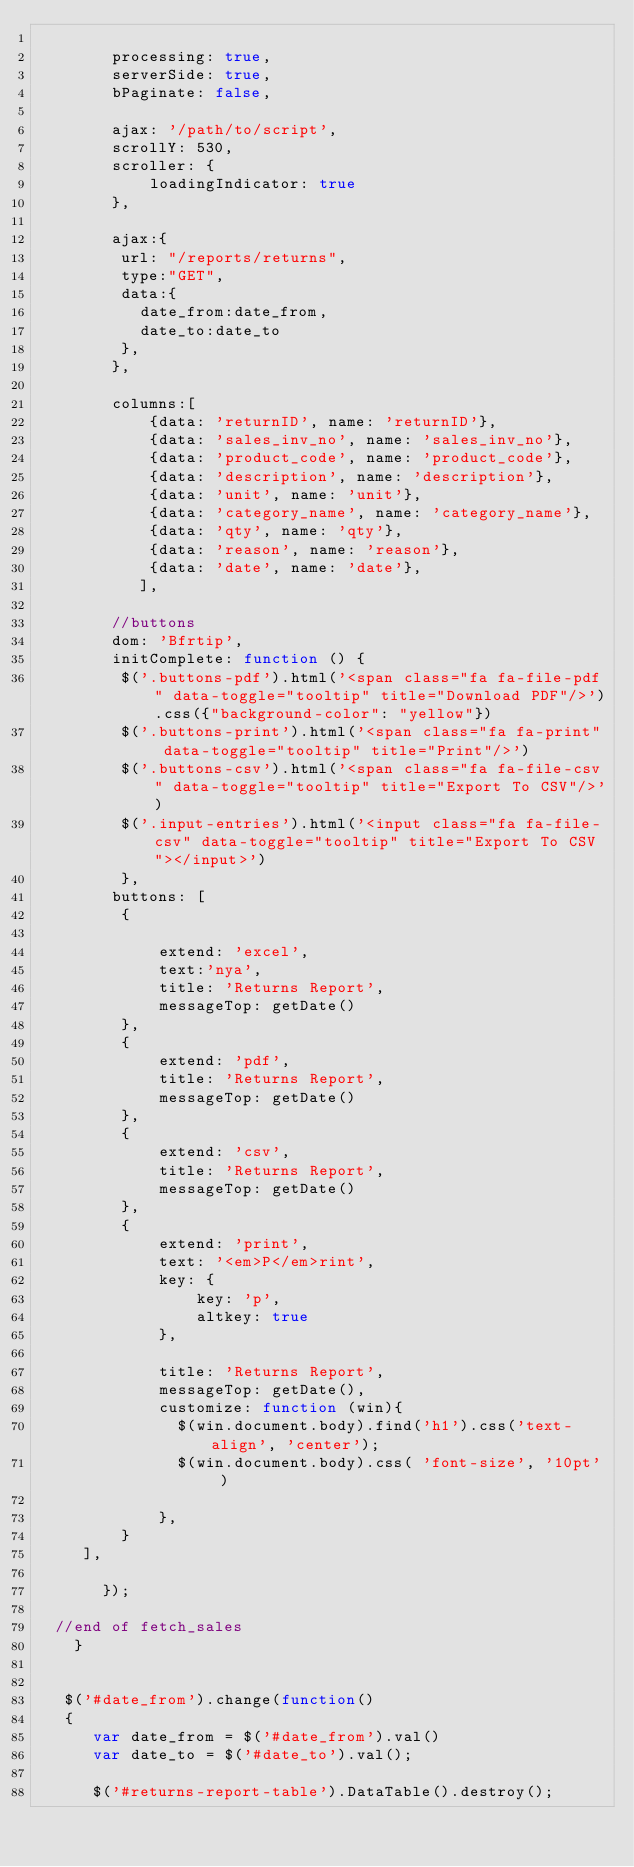Convert code to text. <code><loc_0><loc_0><loc_500><loc_500><_JavaScript_>     
        processing: true,
        serverSide: true,
        bPaginate: false,
 
        ajax: '/path/to/script',
        scrollY: 530,
        scroller: {
            loadingIndicator: true
        },
      
        ajax:{
         url: "/reports/returns",
         type:"GET",
         data:{
           date_from:date_from,
           date_to:date_to
         },
        }, 
        
        columns:[       
            {data: 'returnID', name: 'returnID'},
            {data: 'sales_inv_no', name: 'sales_inv_no'},
            {data: 'product_code', name: 'product_code'},
            {data: 'description', name: 'description'},
            {data: 'unit', name: 'unit'},   
            {data: 'category_name', name: 'category_name'},   
            {data: 'qty', name: 'qty'},
            {data: 'reason', name: 'reason'},
            {data: 'date', name: 'date'},
           ],
 
        //buttons
        dom: 'Bfrtip',
        initComplete: function () {
         $('.buttons-pdf').html('<span class="fa fa-file-pdf" data-toggle="tooltip" title="Download PDF"/>').css({"background-color": "yellow"})
         $('.buttons-print').html('<span class="fa fa-print" data-toggle="tooltip" title="Print"/>')
         $('.buttons-csv').html('<span class="fa fa-file-csv" data-toggle="tooltip" title="Export To CSV"/>')
         $('.input-entries').html('<input class="fa fa-file-csv" data-toggle="tooltip" title="Export To CSV"></input>')
         },
        buttons: [
         {
          
             extend: 'excel', 
             text:'nya',       
             title: 'Returns Report',
             messageTop: getDate()
         },
         {
             extend: 'pdf',
             title: 'Returns Report',
             messageTop: getDate()
         },
         {
             extend: 'csv',
             title: 'Returns Report',
             messageTop: getDate()
         },
         {
             extend: 'print',
             text: '<em>P</em>rint',
             key: {
                 key: 'p',
                 altkey: true
             },
             
             title: 'Returns Report',
             messageTop: getDate(),                
             customize: function (win){
               $(win.document.body).find('h1').css('text-align', 'center');
               $(win.document.body).css( 'font-size', '10pt' )
                   
             },
         }
     ],
        
       });
 
  //end of fetch_sales
    }

    
   $('#date_from').change(function()
   {
      var date_from = $('#date_from').val()
      var date_to = $('#date_to').val();

      $('#returns-report-table').DataTable().destroy();</code> 